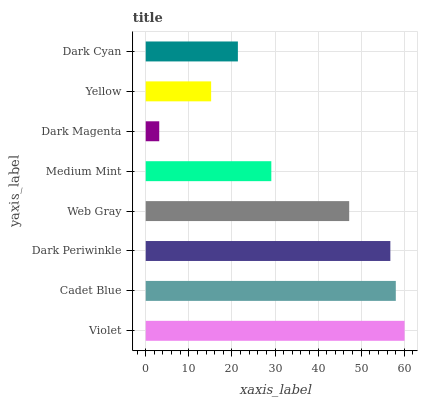Is Dark Magenta the minimum?
Answer yes or no. Yes. Is Violet the maximum?
Answer yes or no. Yes. Is Cadet Blue the minimum?
Answer yes or no. No. Is Cadet Blue the maximum?
Answer yes or no. No. Is Violet greater than Cadet Blue?
Answer yes or no. Yes. Is Cadet Blue less than Violet?
Answer yes or no. Yes. Is Cadet Blue greater than Violet?
Answer yes or no. No. Is Violet less than Cadet Blue?
Answer yes or no. No. Is Web Gray the high median?
Answer yes or no. Yes. Is Medium Mint the low median?
Answer yes or no. Yes. Is Violet the high median?
Answer yes or no. No. Is Cadet Blue the low median?
Answer yes or no. No. 